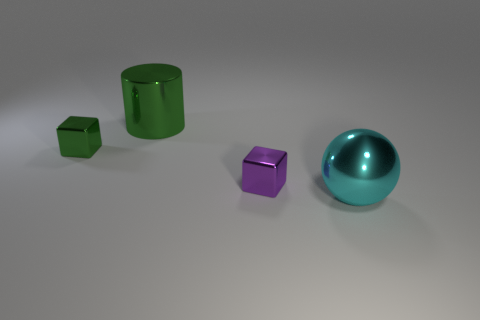What is the color of the large thing that is behind the large cyan metallic ball?
Make the answer very short. Green. What number of other objects are the same color as the metal cylinder?
Give a very brief answer. 1. There is a shiny object on the left side of the green cylinder; is its size the same as the metal sphere?
Give a very brief answer. No. Is there anything else that is the same shape as the big cyan shiny thing?
Keep it short and to the point. No. How many metallic objects are big cylinders or cyan balls?
Give a very brief answer. 2. Are there fewer small green cubes that are on the right side of the cyan metallic thing than big cylinders?
Your answer should be very brief. Yes. What shape is the tiny metal object that is behind the block that is right of the green object that is in front of the metal cylinder?
Keep it short and to the point. Cube. Are there more small gray spheres than small metal objects?
Your response must be concise. No. What number of other objects are the same material as the big green cylinder?
Ensure brevity in your answer.  3. What number of things are tiny purple objects or large shiny things that are right of the large green metallic object?
Offer a very short reply. 2. 